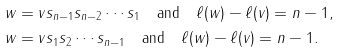<formula> <loc_0><loc_0><loc_500><loc_500>& w = v s _ { n - 1 } s _ { n - 2 } \cdots s _ { 1 } \quad \text {and} \quad \ell ( w ) - \ell ( v ) = n - 1 , \\ & w = v s _ { 1 } s _ { 2 } \cdots s _ { n - 1 } \quad \text {and} \quad \ell ( w ) - \ell ( v ) = n - 1 .</formula> 